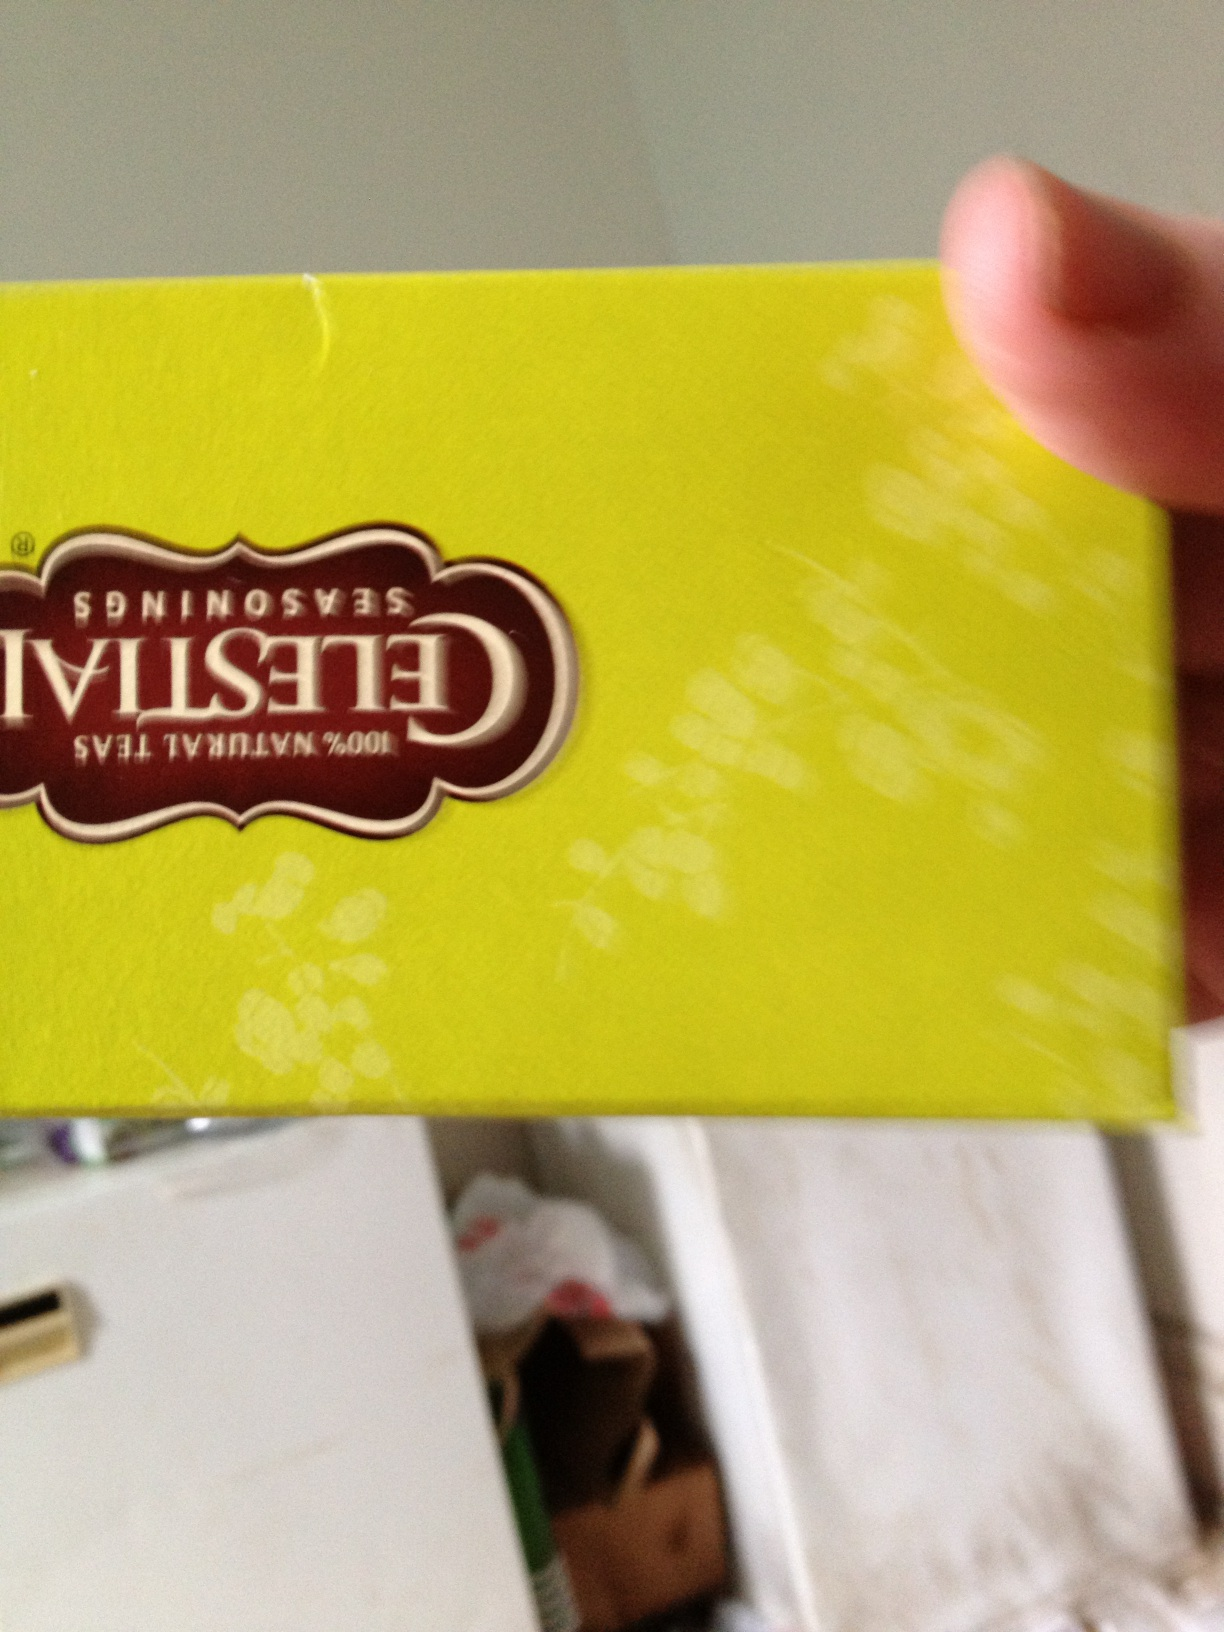What other products does this brand offer? Celestial Seasonings offers a diverse range of products beyond their famous tea blends. These include herbal supplements, wellness drinks, and various seasonal and specialty teas. Their product line is designed to cater to different health and wellness needs, including stress relief, sleep support, and digestive health. Each product typically features the sharegpt4v/same commitment to natural ingredients and quality that the brand is known for. Describe a relaxing evening with a cup of this tea. Picture yourself on a cozy evening, wrapped in a warm blanket as you sit by the fireplace. The room is softly lit with candles, their gentle flicker bringing a sense of calm. You hold a steaming cup of Celestial Seasonings tea, the aromatic steam rising to fill the air with soothing scents of chamomile and lavender. As you take a sip, the natural flavors and warmth of the tea flow through you, easing away the stresses of the day. With a good book in your hand and perhaps soft music playing in the background, you find yourself sinking into a state of blissful relaxation. The combination of the tea's comforting taste and the peaceful environment creates the perfect end to your day, allowing you to unwind and prepare for a restful night’s sleep. How could this tea be part of a dinner gathering? Celestial Seasonings tea can add a delightful touch to a dinner gathering. For instance, you can serve a light herbal tea as a refreshing welcome drink. During the meal, you might pair specific teas with each course to enhance the flavors, such as a robust black tea with the main course or a floral green tea with dessert. To create a memorable experience, consider incorporating tea into your recipes, like a lavender tea-infused cake or green tea glaze for your entrée. After dinner, a soothing cup of chamomile or peppermint tea can be a perfect finish, helping guests relax and enjoy pleasant conversation. The versatility and variety of Celestial Seasonings teas make them an excellent addition to any dinner party, offering something for every taste and occasion. 